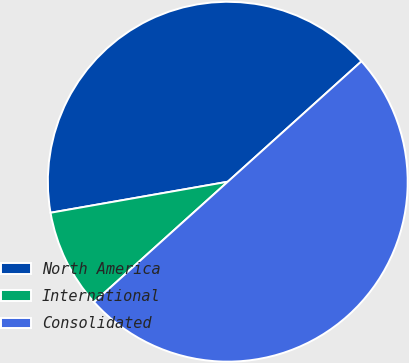<chart> <loc_0><loc_0><loc_500><loc_500><pie_chart><fcel>North America<fcel>International<fcel>Consolidated<nl><fcel>41.09%<fcel>8.91%<fcel>50.0%<nl></chart> 